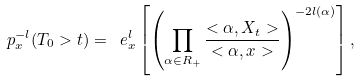<formula> <loc_0><loc_0><loc_500><loc_500>\ p _ { x } ^ { - l } ( T _ { 0 } > t ) = \ e _ { x } ^ { l } \left [ \left ( \prod _ { \alpha \in R _ { + } } \frac { < \alpha , X _ { t } > } { < \alpha , x > } \right ) ^ { - 2 l ( \alpha ) } \right ] ,</formula> 